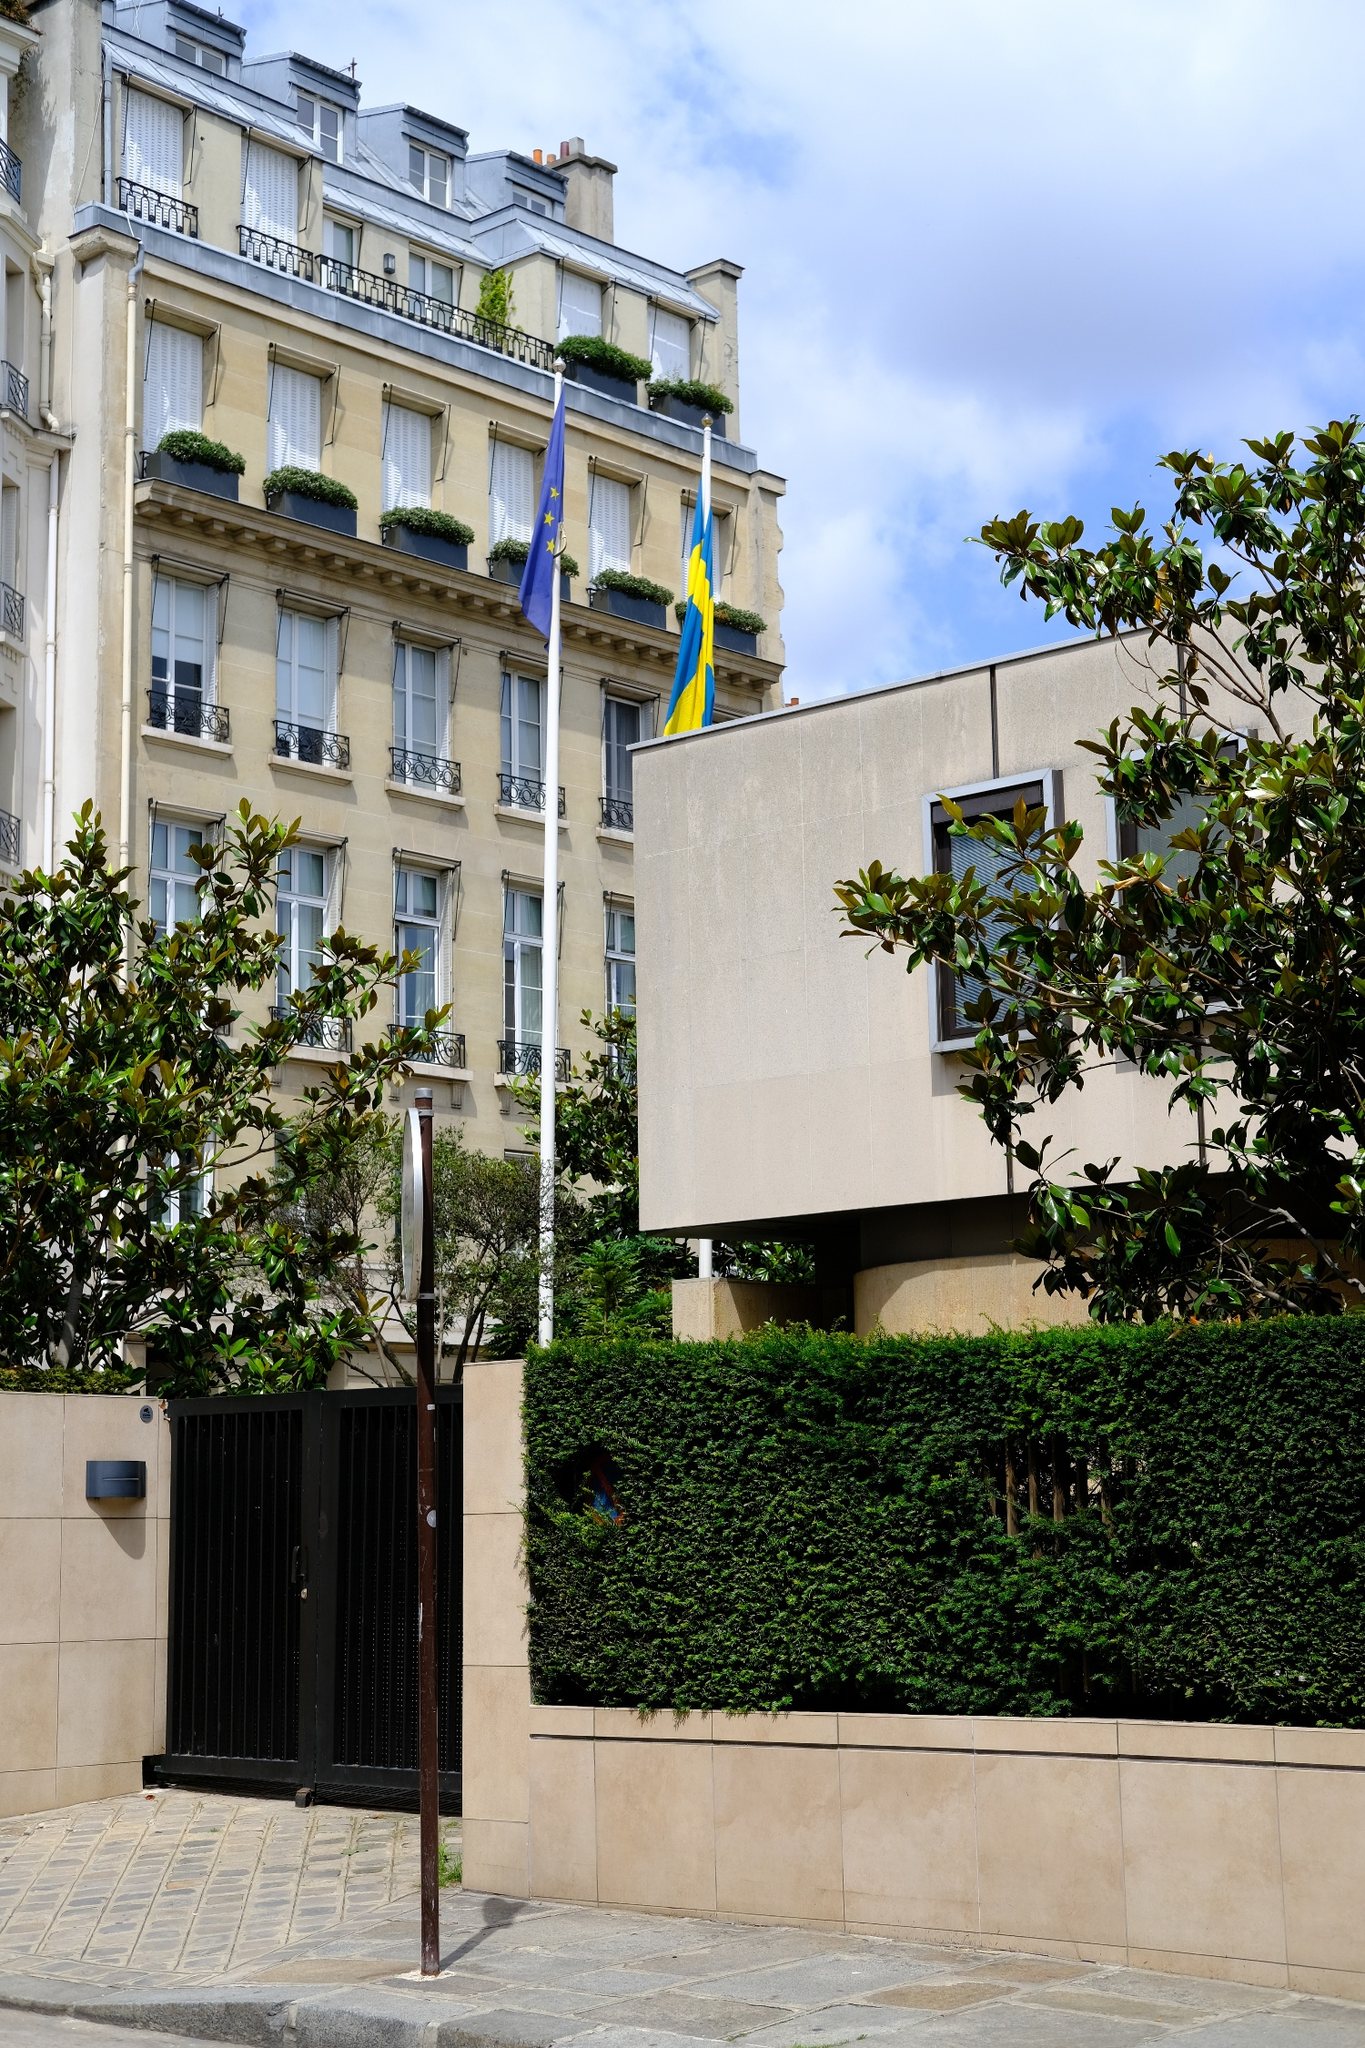Can you elaborate on the elements of the picture provided? The image captures a charming street scene that appears to be in Paris, France. Dominating the frame is a stately beige building, its architecture reminiscent of the classic European style with elegant window dividers and balcony railings. Two flags flutter proudly from a flagpole attached to the building - one representing the European Union with its circle of stars on a blue background, and the other, the Swedish flag, with its bold yellow cross on a blue field. The building is nestled amidst lush greenery, with trees lending a touch of nature to the urban landscape. The perspective of the image is particularly striking, taken from street level and looking up, it gives a sense of grandeur to the building and the scene as a whole. Notably, the identifier 'sa_15935' doesn't provide specific information about the landmark, suggesting that the image stands out on its own merits of beauty and elegance. 